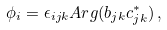Convert formula to latex. <formula><loc_0><loc_0><loc_500><loc_500>\phi _ { i } = \epsilon _ { i j k } A r g ( b _ { j k } c _ { j k } ^ { * } ) \, ,</formula> 